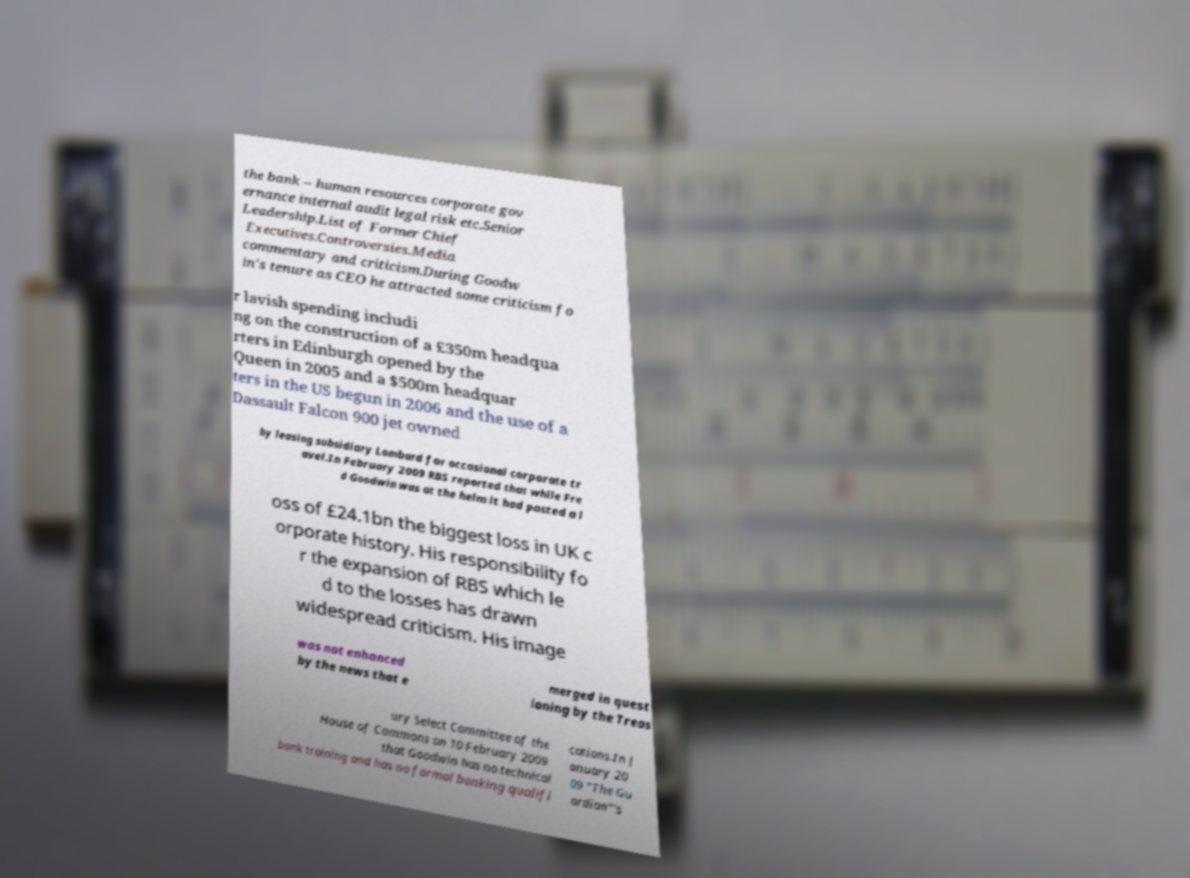There's text embedded in this image that I need extracted. Can you transcribe it verbatim? the bank – human resources corporate gov ernance internal audit legal risk etc.Senior Leadership.List of Former Chief Executives.Controversies.Media commentary and criticism.During Goodw in's tenure as CEO he attracted some criticism fo r lavish spending includi ng on the construction of a £350m headqua rters in Edinburgh opened by the Queen in 2005 and a $500m headquar ters in the US begun in 2006 and the use of a Dassault Falcon 900 jet owned by leasing subsidiary Lombard for occasional corporate tr avel.In February 2009 RBS reported that while Fre d Goodwin was at the helm it had posted a l oss of £24.1bn the biggest loss in UK c orporate history. His responsibility fo r the expansion of RBS which le d to the losses has drawn widespread criticism. His image was not enhanced by the news that e merged in quest ioning by the Treas ury Select Committee of the House of Commons on 10 February 2009 that Goodwin has no technical bank training and has no formal banking qualifi cations.In J anuary 20 09 "The Gu ardian"'s 